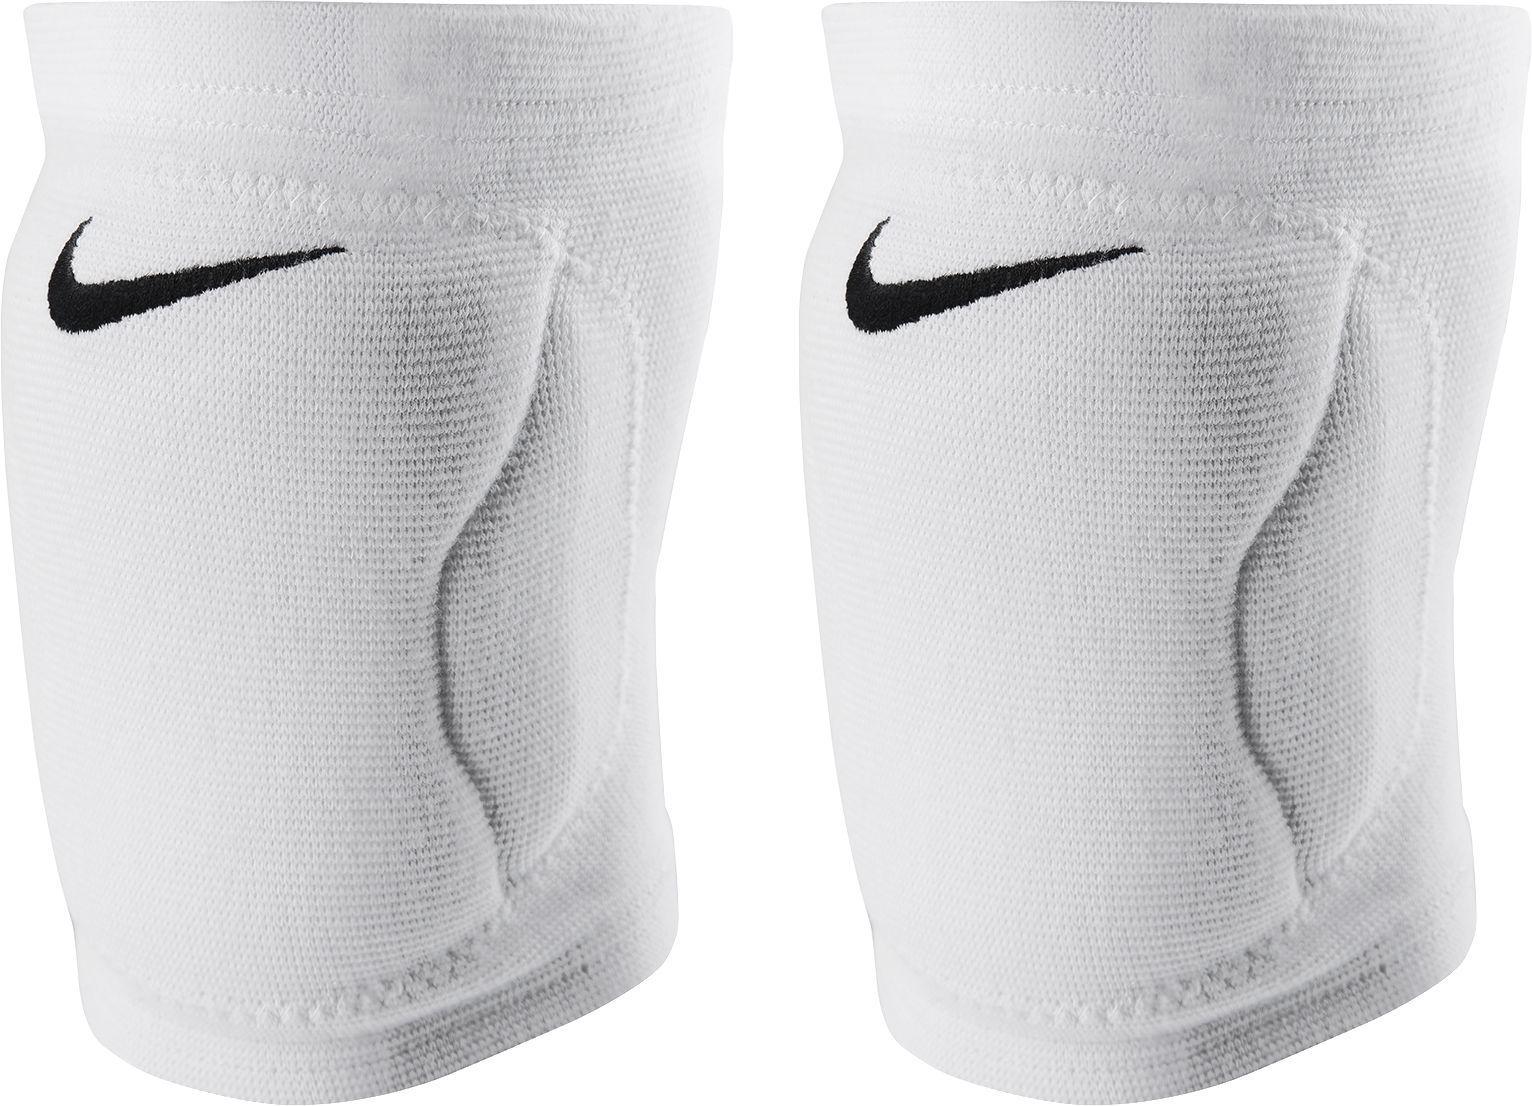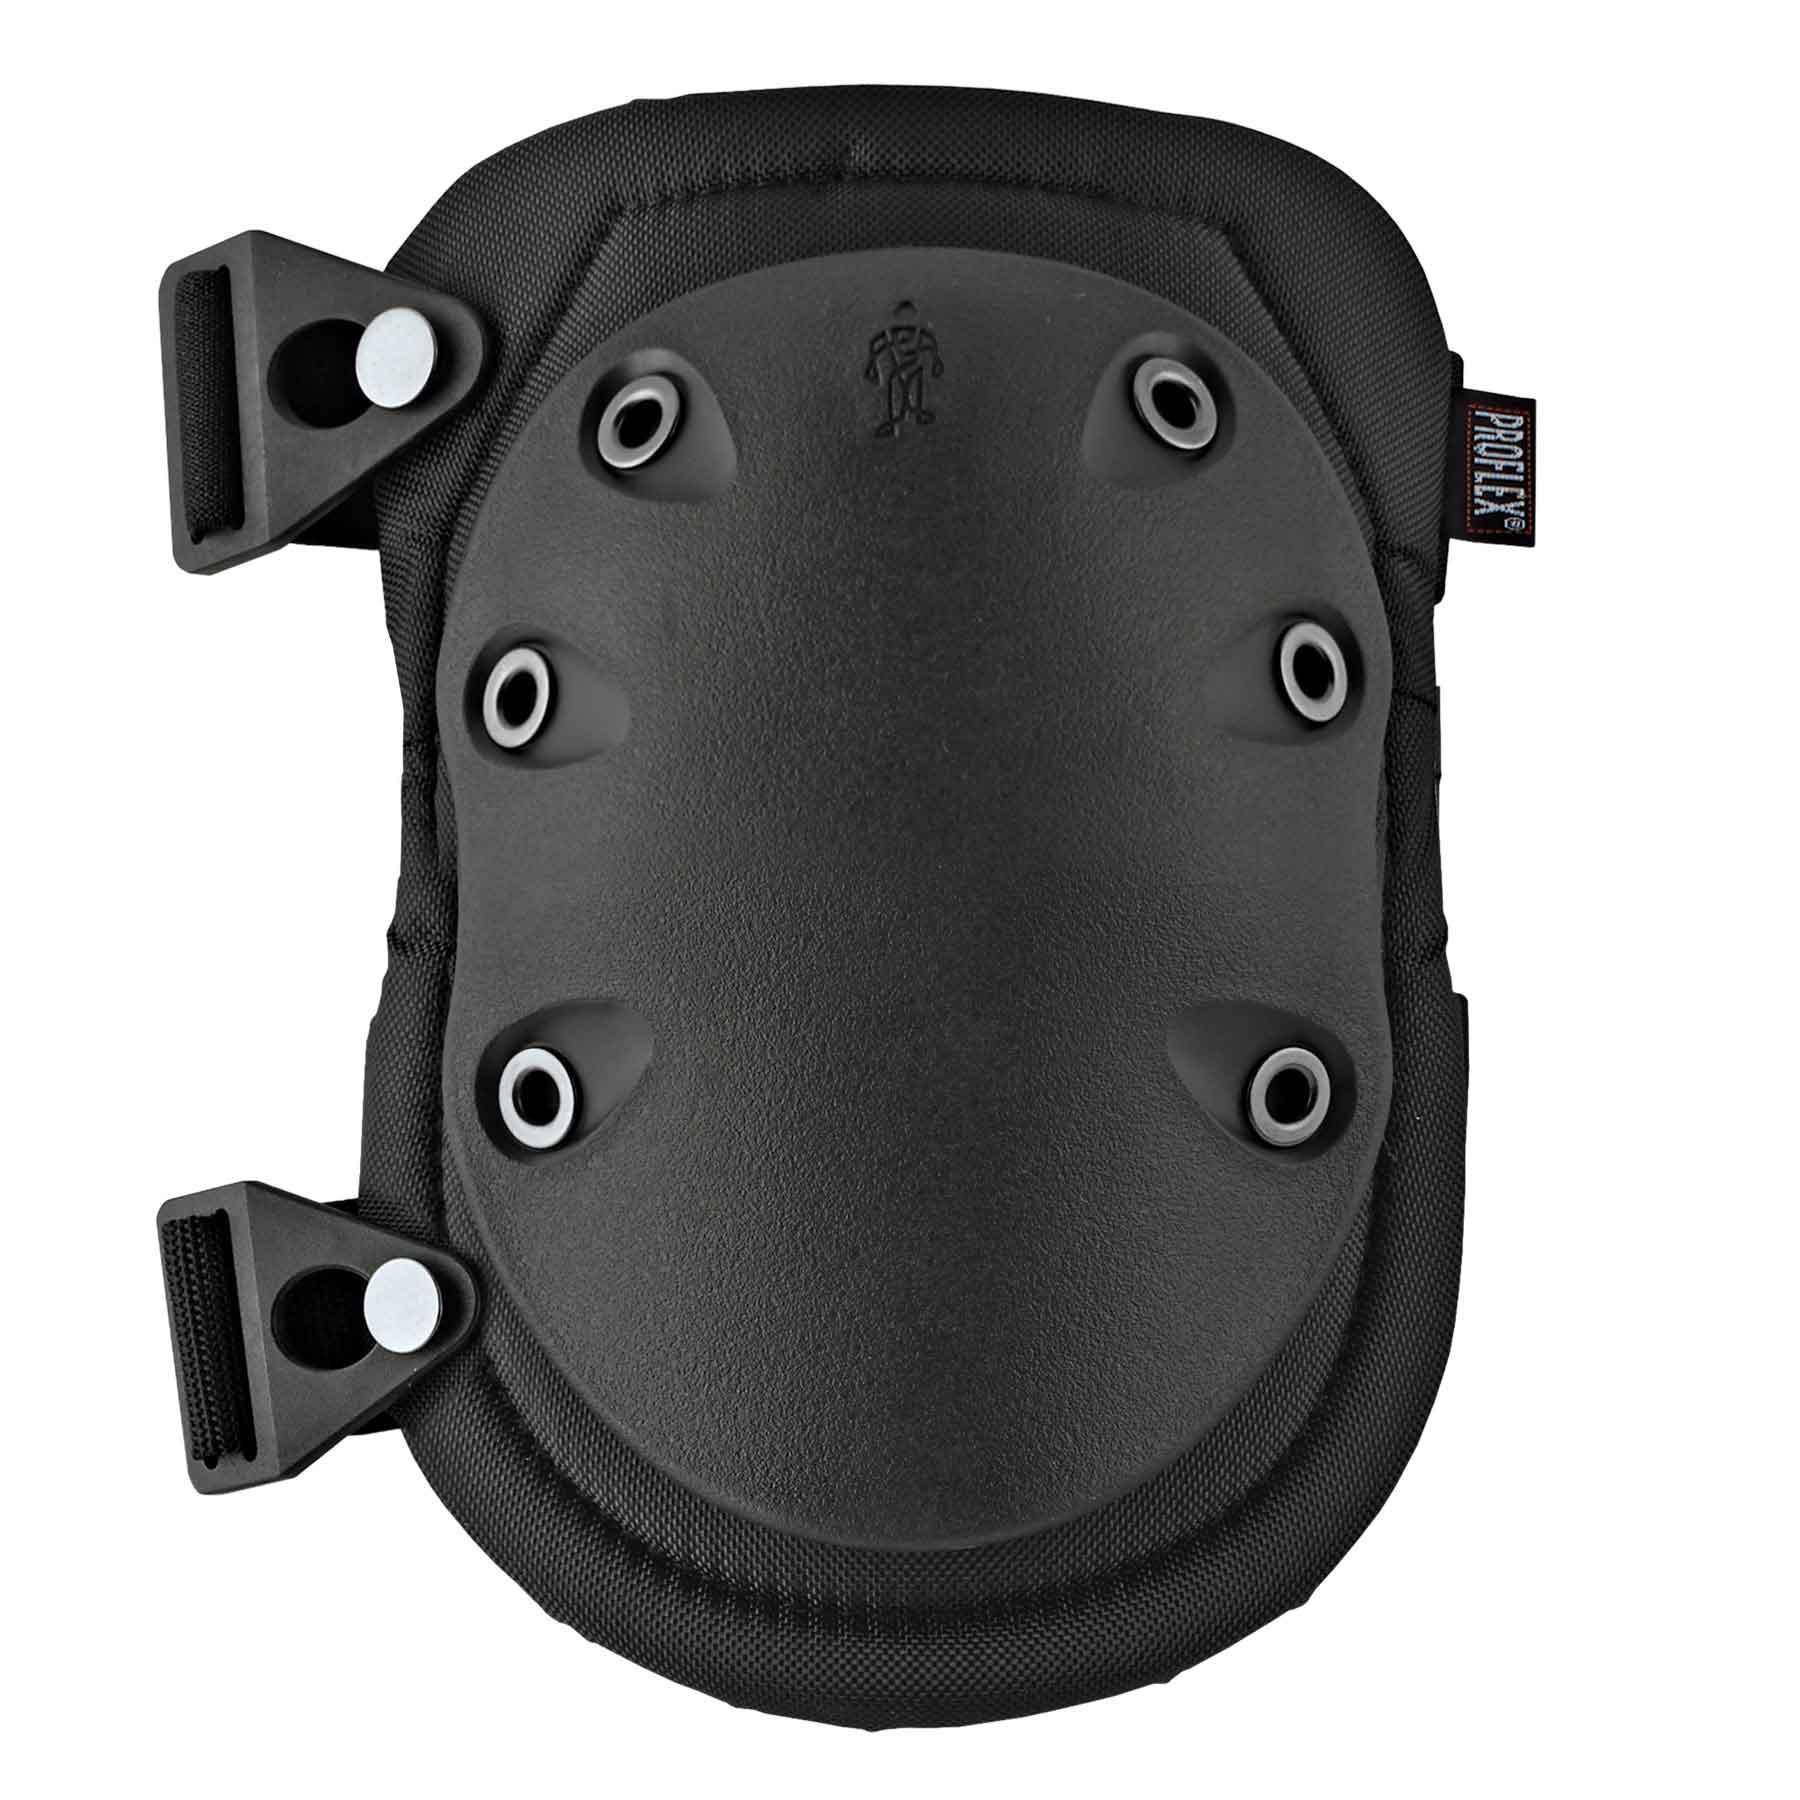The first image is the image on the left, the second image is the image on the right. Examine the images to the left and right. Is the description "One of the pairs of pads is incomplete." accurate? Answer yes or no. Yes. The first image is the image on the left, the second image is the image on the right. Given the left and right images, does the statement "Each image shows a pair of black knee pads." hold true? Answer yes or no. No. 